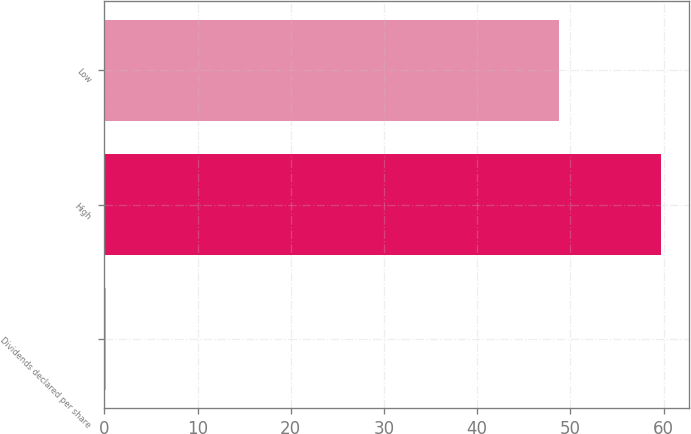Convert chart. <chart><loc_0><loc_0><loc_500><loc_500><bar_chart><fcel>Dividends declared per share<fcel>High<fcel>Low<nl><fcel>0.15<fcel>59.72<fcel>48.76<nl></chart> 